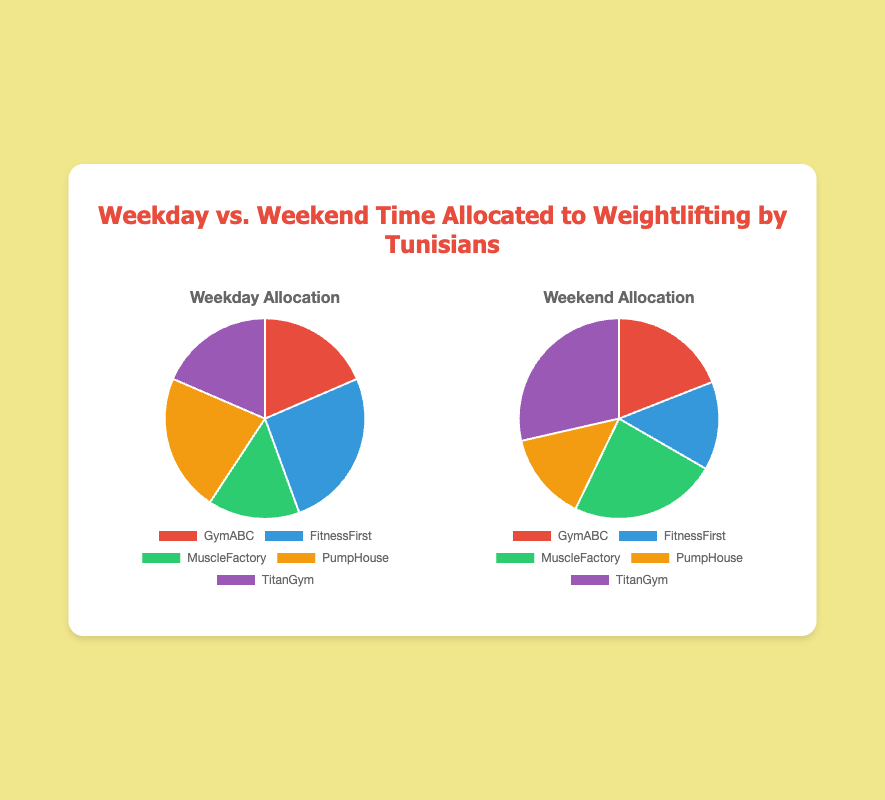Which gym has the highest weekday time allocation? By observing the weekday pie chart, the largest slice corresponds to the data point with the highest value. From the data, FitnessFirst has the largest allocation of 35.
Answer: FitnessFirst Which gym has the lowest weekend time allocation? By looking at the weekend pie chart, the smallest slice is the one with the smallest value. From the data, both FitnessFirst and PumpHouse have the lowest allocation of 15.
Answer: FitnessFirst and PumpHouse How does the total weekday time allocation compare to the total weekend time allocation? Sum up all time allocations for both weekday and weekend. From the data, weekday total is 135, and weekend total is 105. Thus, weekday has a higher total allocation.
Answer: Weekday has more What is the combined allocation for MuscleFactory across weekdays and weekends? Add the weekday allocation for MuscleFactory (20) to the weekend allocation (25). The combined allocation is 20 + 25 = 45.
Answer: 45 Which gyms have equal time allocation during weekdays? Identify the gyms with matching values in the weekday chart. Both GymABC and TitanGym have an allocation of 25 on weekdays.
Answer: GymABC and TitanGym Which period has more time allocated to TitanGym, weekday or weekend? Compare the slices for TitanGym in both charts. TitanGym has 25 on weekdays and 30 on weekends, so more time is allocated on weekends.
Answer: Weekend If you sum the allocations for FitnessFirst on weekdays and weekends, what is the total? Add FitnessFirst's weekday allocation (35) to the weekend allocation (15). The total is 35 + 15 = 50.
Answer: 50 What percentage of total weekend time is allocated to MuscleFactory? Calculate MuscleFactory's percentage share by dividing its weekend allocation (25) by the total weekend time (105) and multiplying by 100. (25/105) * 100 ≈ 23.81%.
Answer: 23.81% By how much does PumpHouse's weekday allocation exceed its weekend allocation? Subtract PumpHouse's weekend time (15) from its weekday time (30). The difference is 30 - 15 = 15.
Answer: 15 What is the visual color representation for FitnessFirst in the charts? From the color scheme in the code and observing the chart, FitnessFirst is represented by the blue slice.
Answer: Blue 